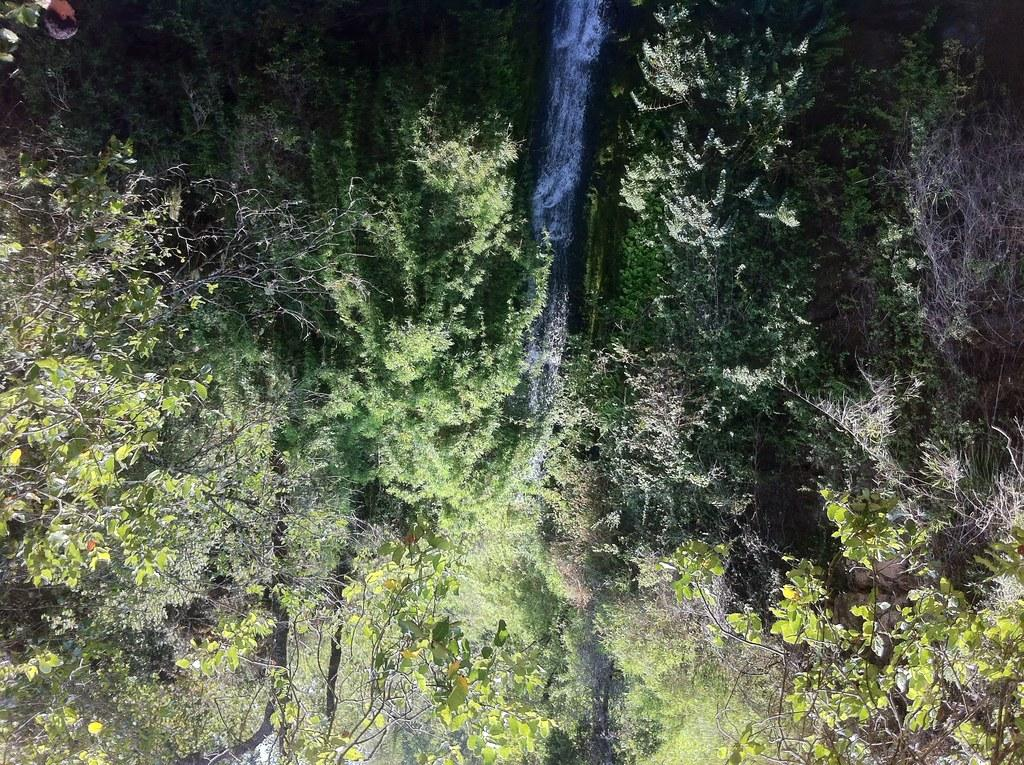What type of vegetation can be seen in the image? There are trees in the image. What is the primary element that is flowing in the image? Water is flowing in the image. Can you tell me how many secretaries are walking down the alley in the image? There are no secretaries or alleys present in the image; it features trees and flowing water. What type of fly can be seen buzzing around the trees in the image? There are no flies present in the image; it only features trees and flowing water. 